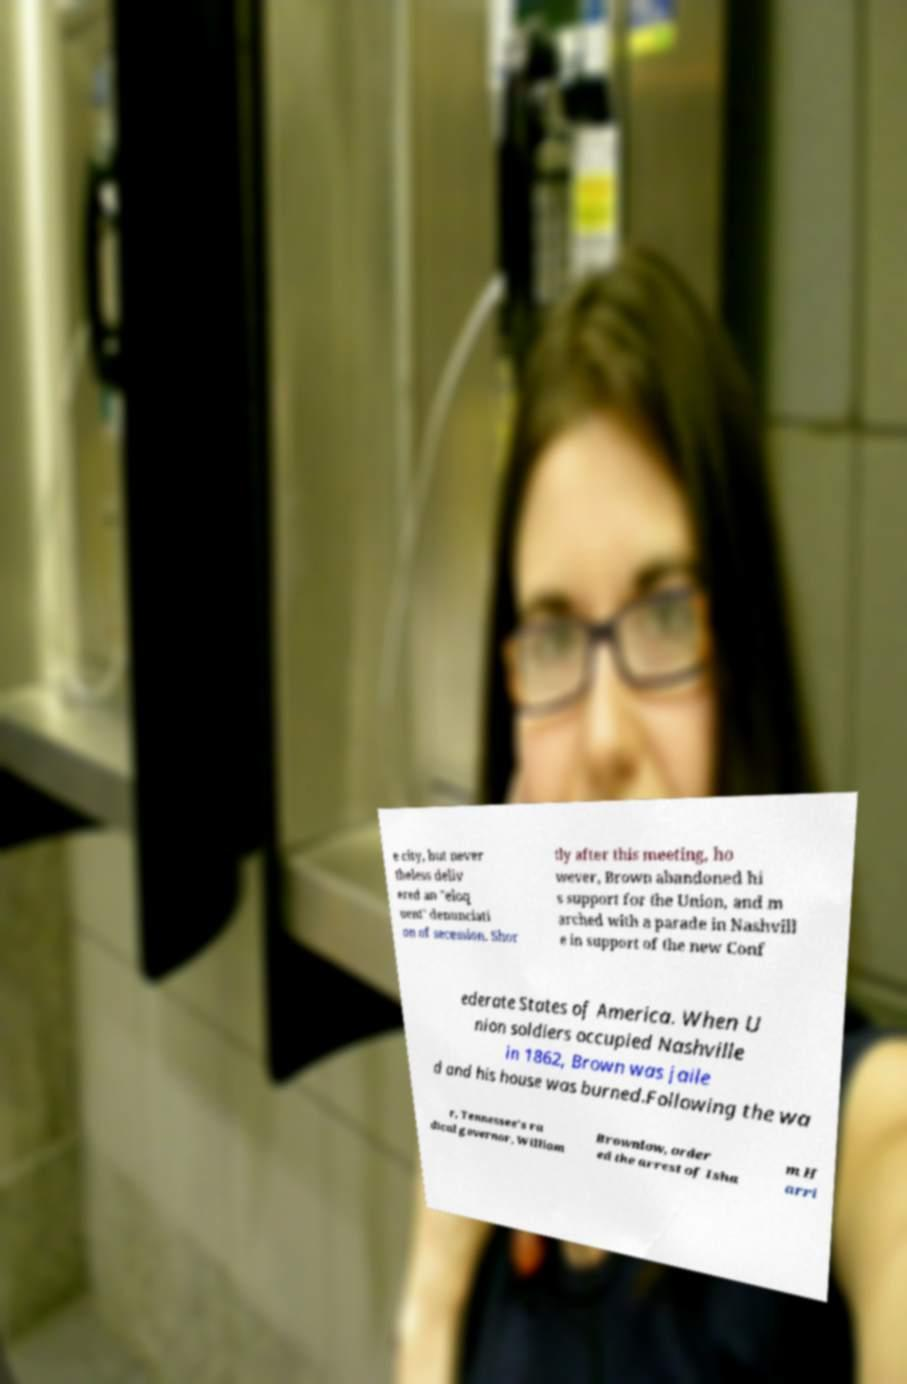There's text embedded in this image that I need extracted. Can you transcribe it verbatim? e city, but never theless deliv ered an "eloq uent" denunciati on of secession. Shor tly after this meeting, ho wever, Brown abandoned hi s support for the Union, and m arched with a parade in Nashvill e in support of the new Conf ederate States of America. When U nion soldiers occupied Nashville in 1862, Brown was jaile d and his house was burned.Following the wa r, Tennessee's ra dical governor, William Brownlow, order ed the arrest of Isha m H arri 